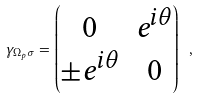<formula> <loc_0><loc_0><loc_500><loc_500>\gamma _ { \Omega _ { p } \sigma } = \begin{pmatrix} 0 & e ^ { i \theta } \\ \pm e ^ { i \theta } & 0 \end{pmatrix} \ ,</formula> 